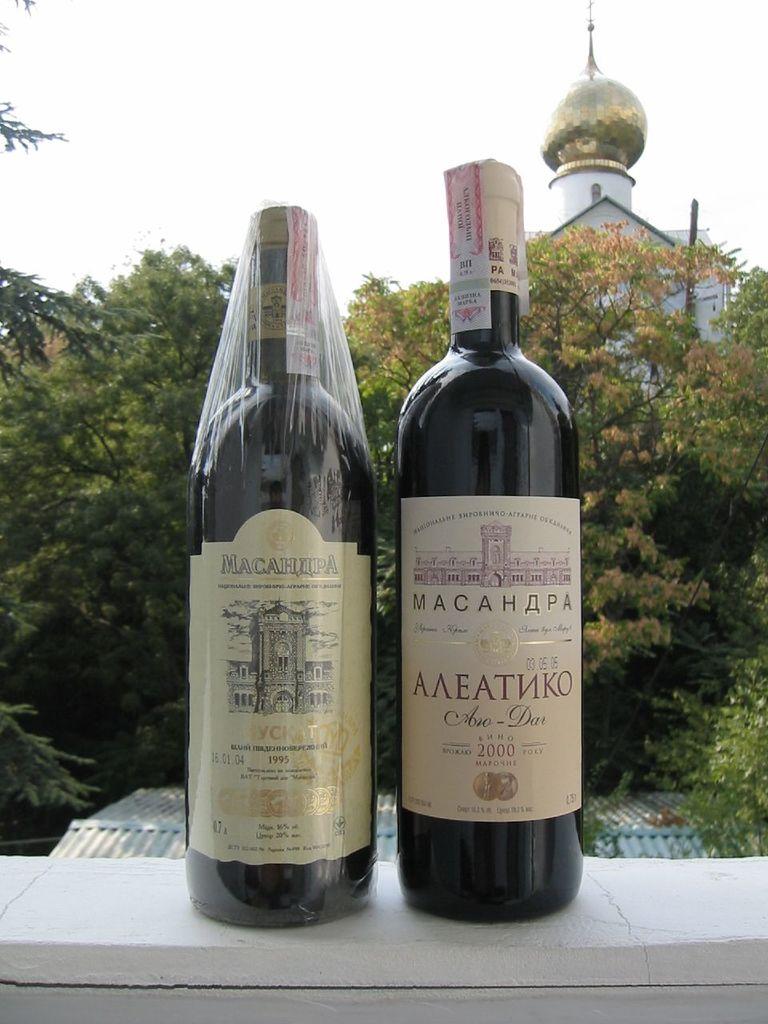What is inside of these bottles?
Your answer should be very brief. Wine. 